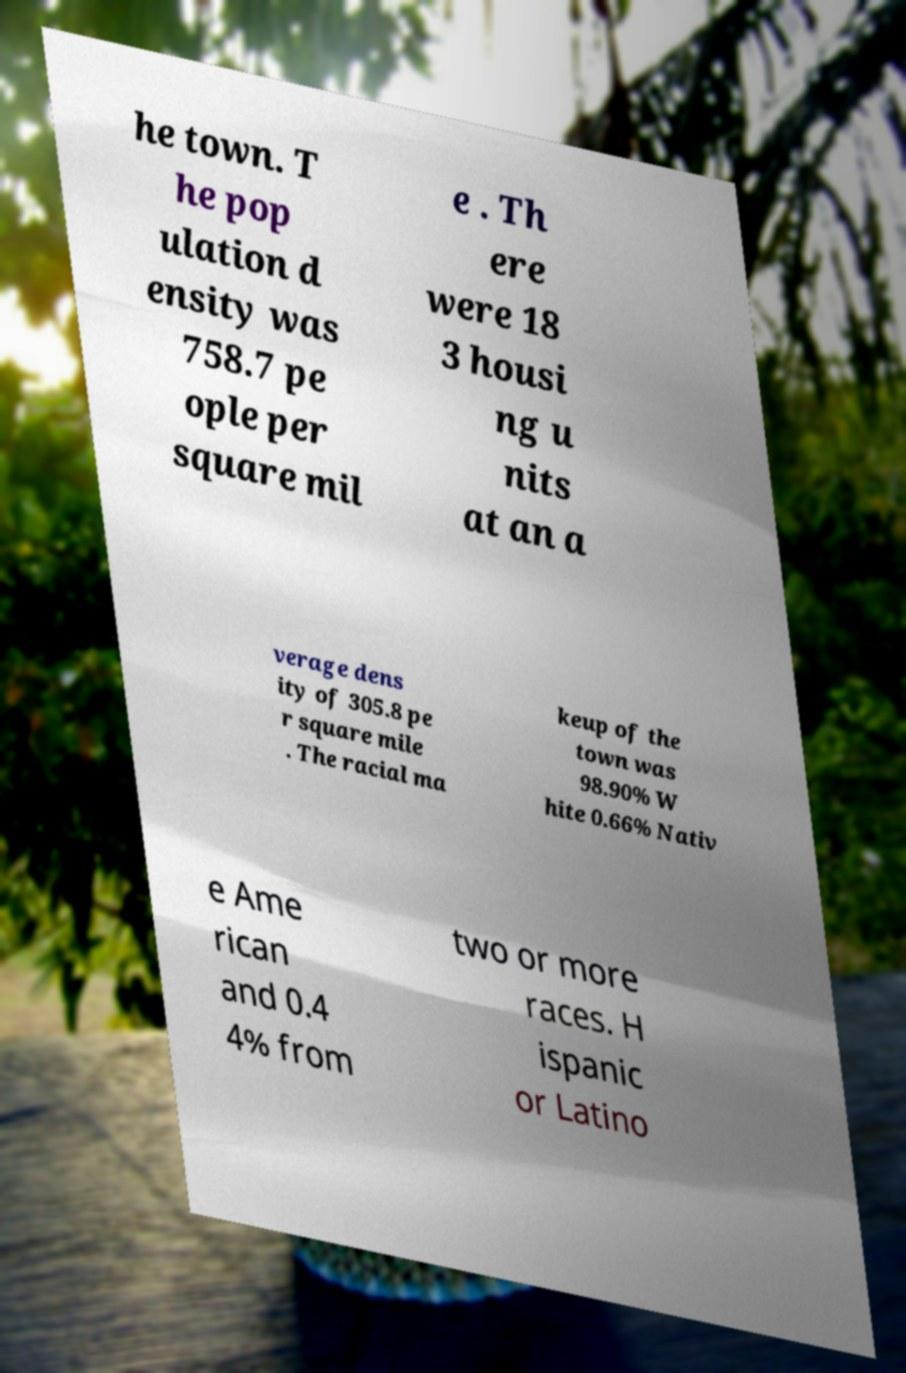Can you accurately transcribe the text from the provided image for me? he town. T he pop ulation d ensity was 758.7 pe ople per square mil e . Th ere were 18 3 housi ng u nits at an a verage dens ity of 305.8 pe r square mile . The racial ma keup of the town was 98.90% W hite 0.66% Nativ e Ame rican and 0.4 4% from two or more races. H ispanic or Latino 